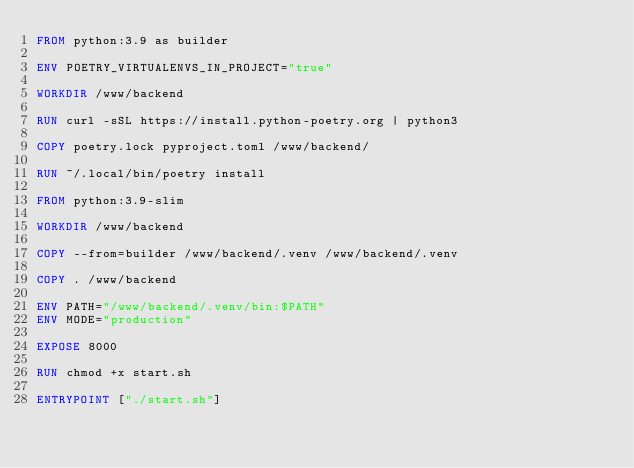Convert code to text. <code><loc_0><loc_0><loc_500><loc_500><_Dockerfile_>FROM python:3.9 as builder

ENV POETRY_VIRTUALENVS_IN_PROJECT="true"

WORKDIR /www/backend

RUN curl -sSL https://install.python-poetry.org | python3

COPY poetry.lock pyproject.toml /www/backend/

RUN ~/.local/bin/poetry install

FROM python:3.9-slim

WORKDIR /www/backend

COPY --from=builder /www/backend/.venv /www/backend/.venv

COPY . /www/backend

ENV PATH="/www/backend/.venv/bin:$PATH"
ENV MODE="production"

EXPOSE 8000

RUN chmod +x start.sh

ENTRYPOINT ["./start.sh"]</code> 